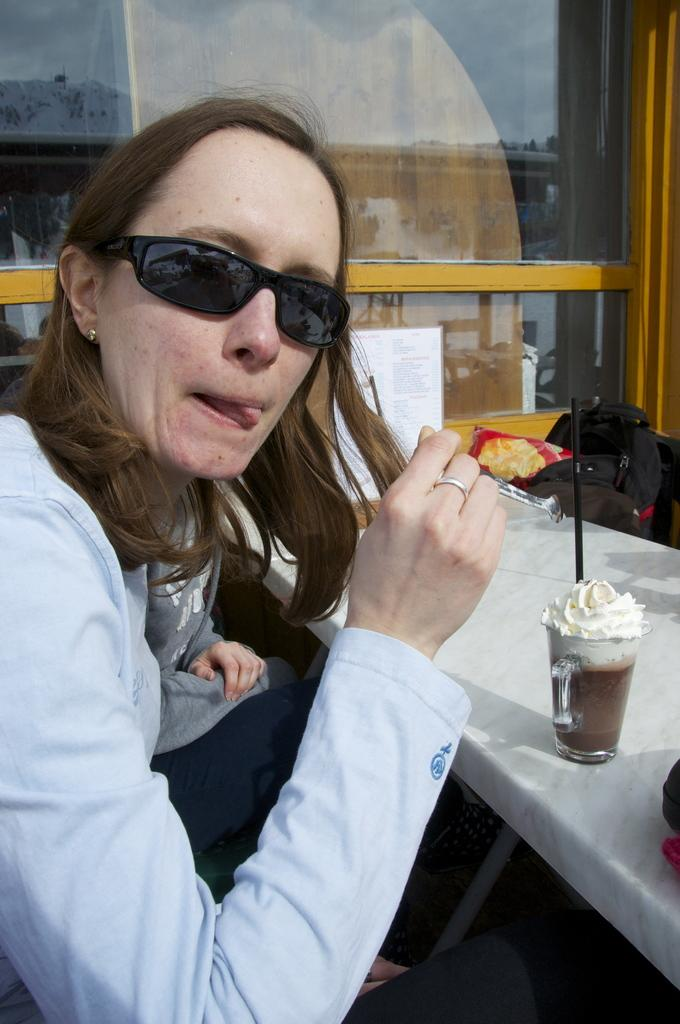What is the main subject of the image? There is a beautiful girl in the image. What is the girl doing in the image? The girl is eating an ice cream. What is the girl wearing in the image? The girl is wearing a dress. What else can be seen in the image besides the girl? There is an ice cream glass on a table in the image. What type of desk can be seen in the image? There is no desk present in the image. What is the value of the bread in the image? There is no bread present in the image, so it's not possible to determine its value. 